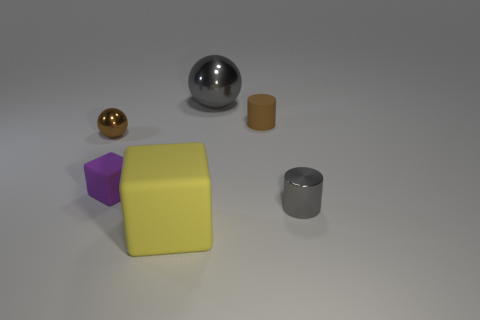Add 3 metal cylinders. How many objects exist? 9 Subtract all balls. How many objects are left? 4 Add 4 tiny brown things. How many tiny brown things exist? 6 Subtract 0 green blocks. How many objects are left? 6 Subtract all purple matte cubes. Subtract all small gray things. How many objects are left? 4 Add 6 gray shiny cylinders. How many gray shiny cylinders are left? 7 